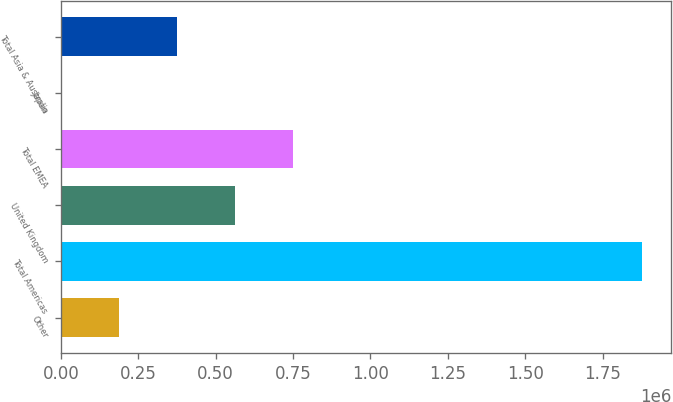Convert chart. <chart><loc_0><loc_0><loc_500><loc_500><bar_chart><fcel>Other<fcel>Total Americas<fcel>United Kingdom<fcel>Total EMEA<fcel>Japan<fcel>Total Asia & Australia<nl><fcel>188112<fcel>1.87791e+06<fcel>563623<fcel>751378<fcel>357<fcel>375867<nl></chart> 